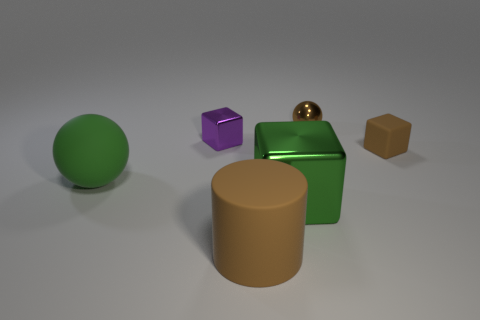Add 4 rubber objects. How many objects exist? 10 Subtract all small cubes. How many cubes are left? 1 Subtract all spheres. How many objects are left? 4 Add 3 tiny brown spheres. How many tiny brown spheres exist? 4 Subtract 0 gray cubes. How many objects are left? 6 Subtract all red metallic cubes. Subtract all small objects. How many objects are left? 3 Add 3 large brown rubber objects. How many large brown rubber objects are left? 4 